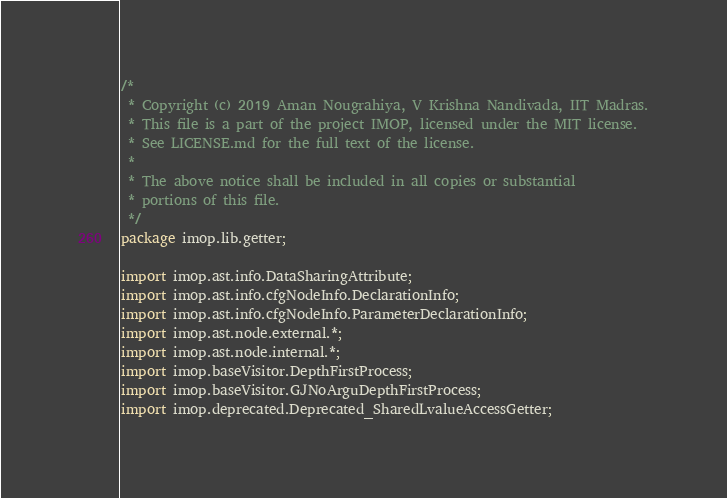Convert code to text. <code><loc_0><loc_0><loc_500><loc_500><_Java_>/*
 * Copyright (c) 2019 Aman Nougrahiya, V Krishna Nandivada, IIT Madras.
 * This file is a part of the project IMOP, licensed under the MIT license.
 * See LICENSE.md for the full text of the license.
 *
 * The above notice shall be included in all copies or substantial
 * portions of this file.
 */
package imop.lib.getter;

import imop.ast.info.DataSharingAttribute;
import imop.ast.info.cfgNodeInfo.DeclarationInfo;
import imop.ast.info.cfgNodeInfo.ParameterDeclarationInfo;
import imop.ast.node.external.*;
import imop.ast.node.internal.*;
import imop.baseVisitor.DepthFirstProcess;
import imop.baseVisitor.GJNoArguDepthFirstProcess;
import imop.deprecated.Deprecated_SharedLvalueAccessGetter;</code> 